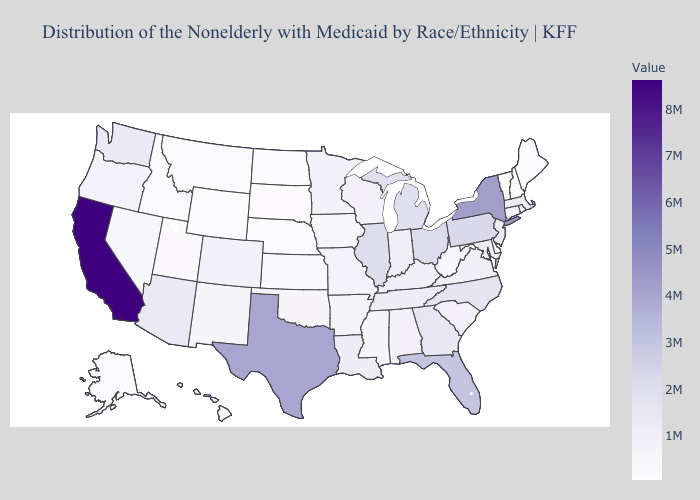Among the states that border California , does Nevada have the highest value?
Concise answer only. No. Does West Virginia have the highest value in the South?
Be succinct. No. Which states hav the highest value in the Northeast?
Be succinct. New York. Which states have the highest value in the USA?
Answer briefly. California. Does Louisiana have a lower value than Texas?
Be succinct. Yes. Does Ohio have the highest value in the MidWest?
Write a very short answer. Yes. Among the states that border South Dakota , does Wyoming have the lowest value?
Concise answer only. Yes. Which states have the highest value in the USA?
Answer briefly. California. 